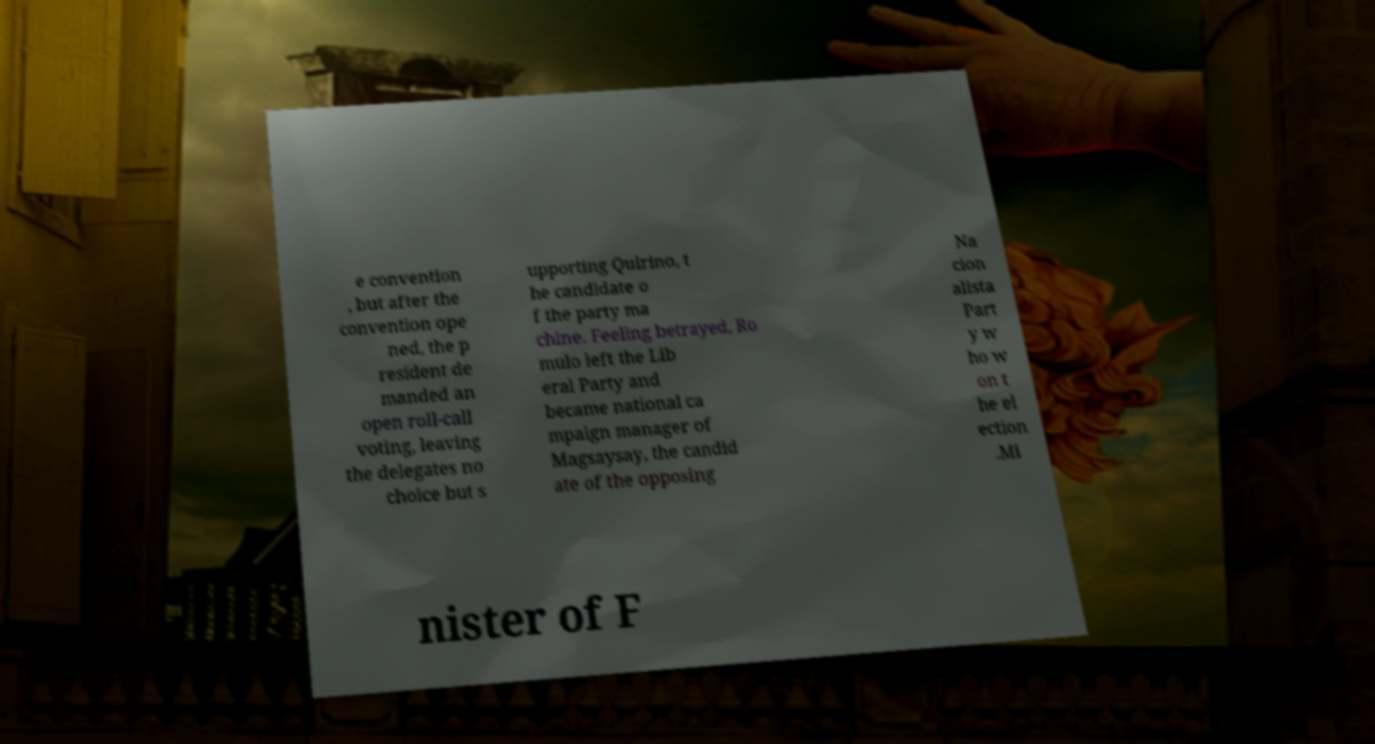What messages or text are displayed in this image? I need them in a readable, typed format. e convention , but after the convention ope ned, the p resident de manded an open roll-call voting, leaving the delegates no choice but s upporting Quirino, t he candidate o f the party ma chine. Feeling betrayed, Ro mulo left the Lib eral Party and became national ca mpaign manager of Magsaysay, the candid ate of the opposing Na cion alista Part y w ho w on t he el ection .Mi nister of F 